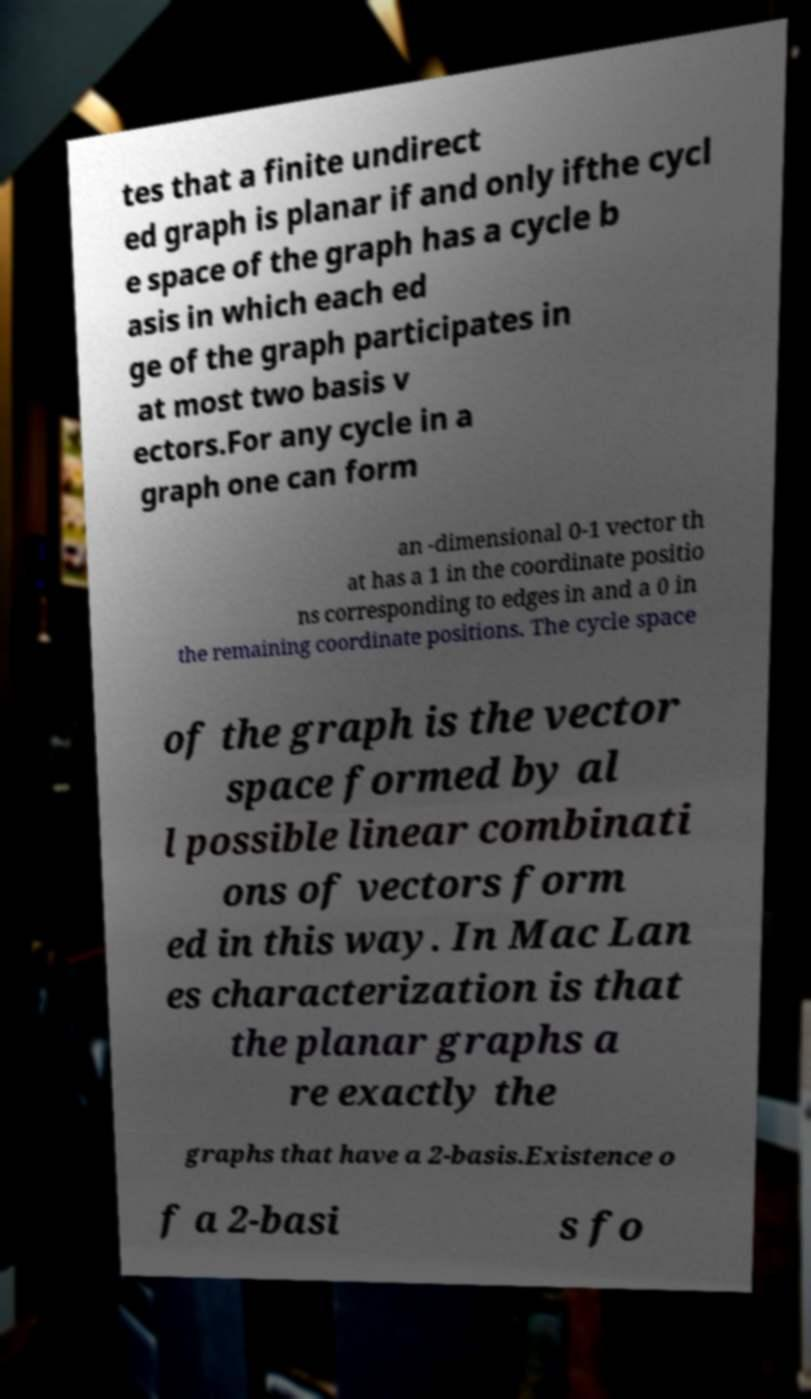For documentation purposes, I need the text within this image transcribed. Could you provide that? tes that a finite undirect ed graph is planar if and only ifthe cycl e space of the graph has a cycle b asis in which each ed ge of the graph participates in at most two basis v ectors.For any cycle in a graph one can form an -dimensional 0-1 vector th at has a 1 in the coordinate positio ns corresponding to edges in and a 0 in the remaining coordinate positions. The cycle space of the graph is the vector space formed by al l possible linear combinati ons of vectors form ed in this way. In Mac Lan es characterization is that the planar graphs a re exactly the graphs that have a 2-basis.Existence o f a 2-basi s fo 